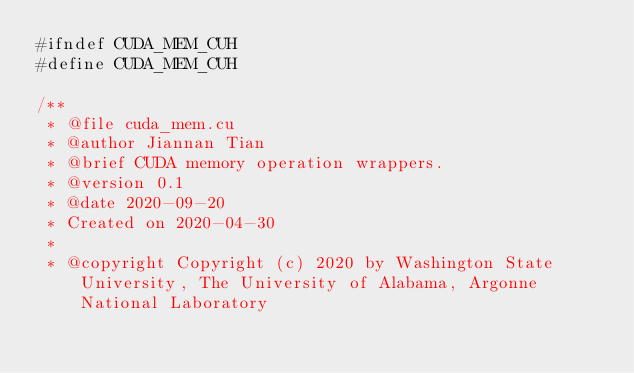Convert code to text. <code><loc_0><loc_0><loc_500><loc_500><_Cuda_>#ifndef CUDA_MEM_CUH
#define CUDA_MEM_CUH

/**
 * @file cuda_mem.cu
 * @author Jiannan Tian
 * @brief CUDA memory operation wrappers.
 * @version 0.1
 * @date 2020-09-20
 * Created on 2020-04-30
 *
 * @copyright Copyright (c) 2020 by Washington State University, The University of Alabama, Argonne National Laboratory</code> 